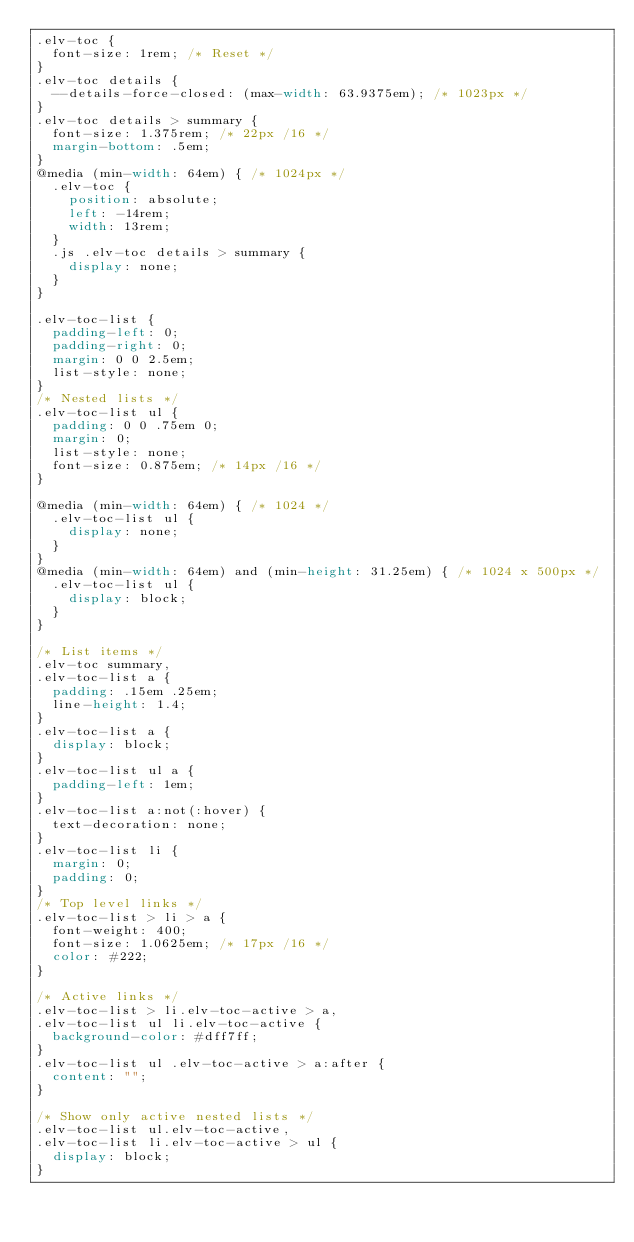Convert code to text. <code><loc_0><loc_0><loc_500><loc_500><_CSS_>.elv-toc {
	font-size: 1rem; /* Reset */
}
.elv-toc details {
	--details-force-closed: (max-width: 63.9375em); /* 1023px */
}
.elv-toc details > summary {
	font-size: 1.375rem; /* 22px /16 */
	margin-bottom: .5em;
}
@media (min-width: 64em) { /* 1024px */
	.elv-toc {
		position: absolute;
		left: -14rem;
		width: 13rem;
	}
	.js .elv-toc details > summary {
		display: none;
	}
}

.elv-toc-list {
	padding-left: 0;
	padding-right: 0;
	margin: 0 0 2.5em;
	list-style: none;
}
/* Nested lists */
.elv-toc-list ul {
	padding: 0 0 .75em 0;
	margin: 0;
	list-style: none;
	font-size: 0.875em; /* 14px /16 */
}

@media (min-width: 64em) { /* 1024 */
	.elv-toc-list ul {
		display: none;
	}
}
@media (min-width: 64em) and (min-height: 31.25em) { /* 1024 x 500px */
	.elv-toc-list ul {
		display: block;
	}
}

/* List items */
.elv-toc summary,
.elv-toc-list a {
	padding: .15em .25em;
	line-height: 1.4;
}
.elv-toc-list a {
	display: block;
}
.elv-toc-list ul a {
	padding-left: 1em;
}
.elv-toc-list a:not(:hover) {
	text-decoration: none;
}
.elv-toc-list li {
	margin: 0;
	padding: 0;
}
/* Top level links */
.elv-toc-list > li > a {
	font-weight: 400;
	font-size: 1.0625em; /* 17px /16 */
	color: #222;
}

/* Active links */
.elv-toc-list > li.elv-toc-active > a,
.elv-toc-list ul li.elv-toc-active {
	background-color: #dff7ff;
}
.elv-toc-list ul .elv-toc-active > a:after {
	content: "";
}

/* Show only active nested lists */
.elv-toc-list ul.elv-toc-active,
.elv-toc-list li.elv-toc-active > ul {
	display: block;
}</code> 